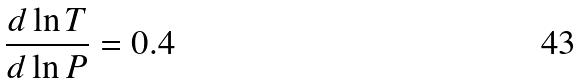Convert formula to latex. <formula><loc_0><loc_0><loc_500><loc_500>\frac { d \ln T } { d \ln P } = 0 . 4</formula> 